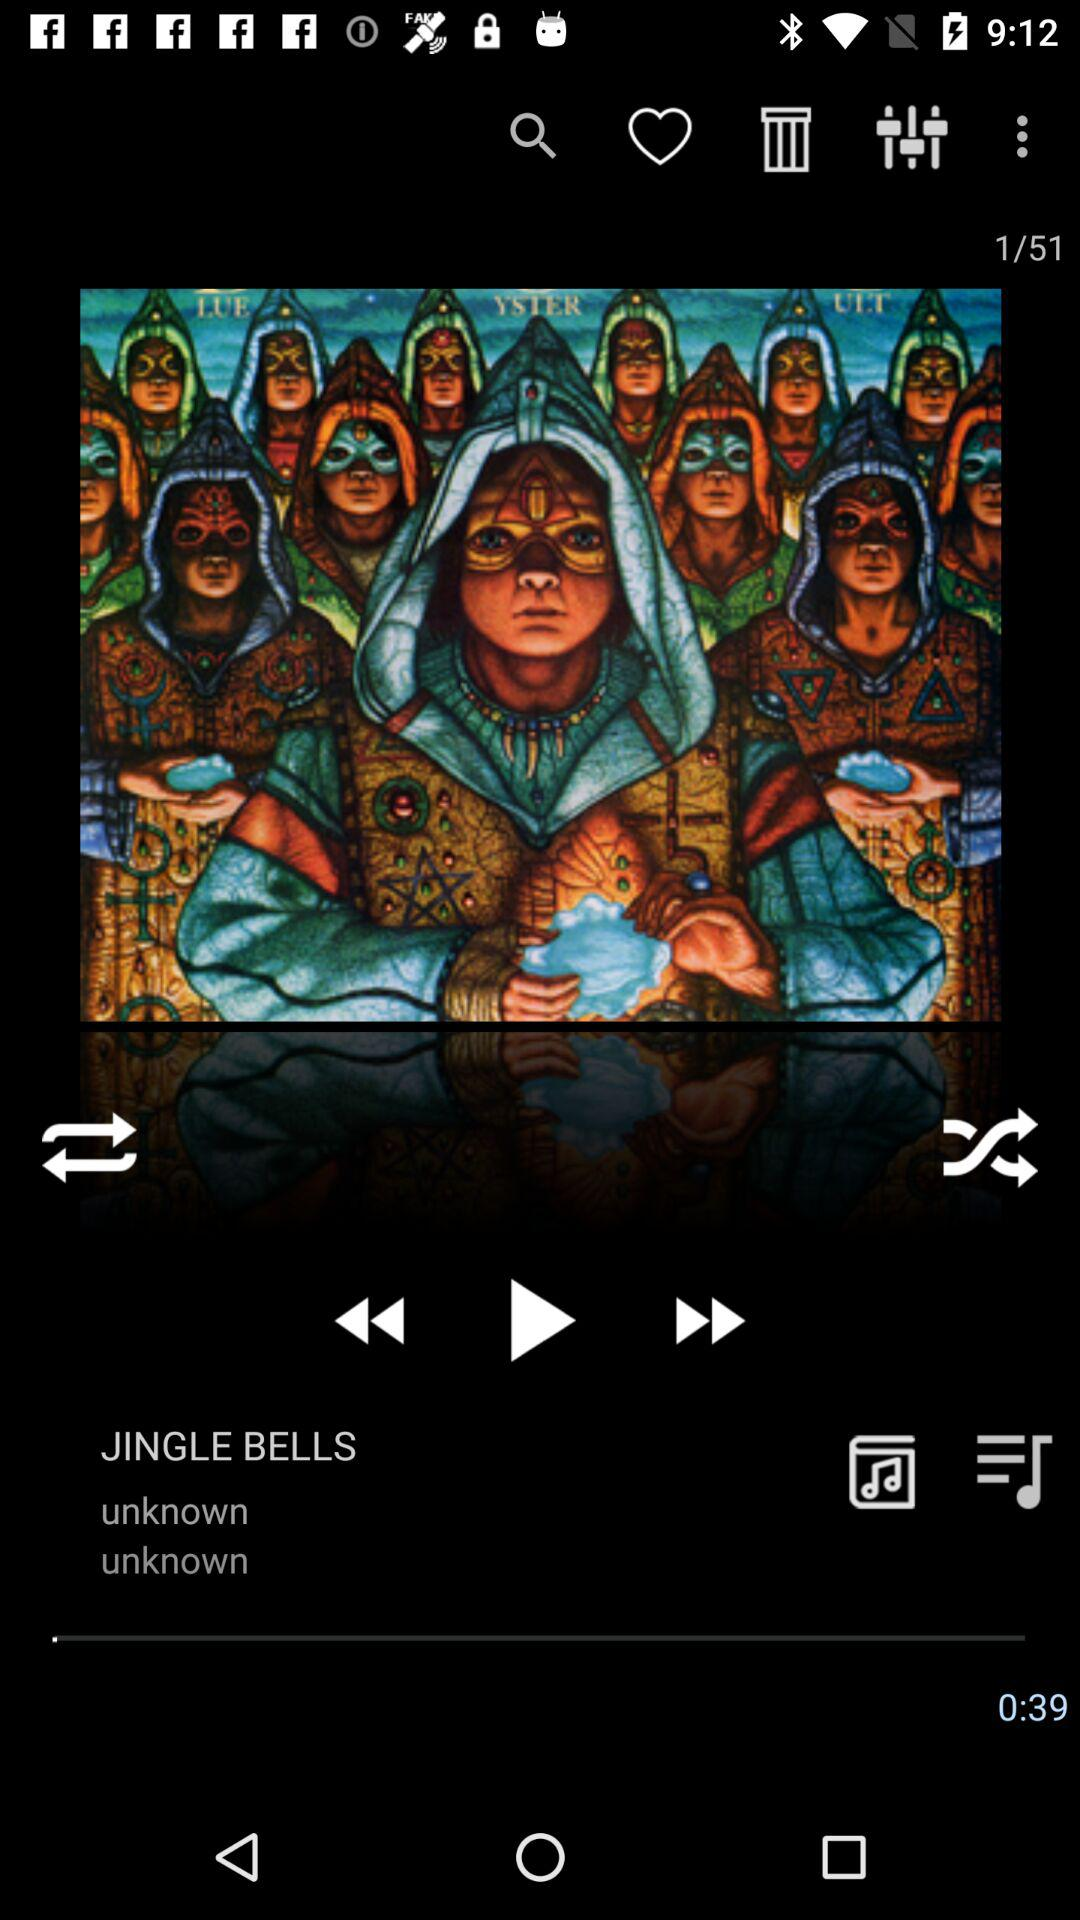What is the total number of tracks? The total number of tracks is 51. 